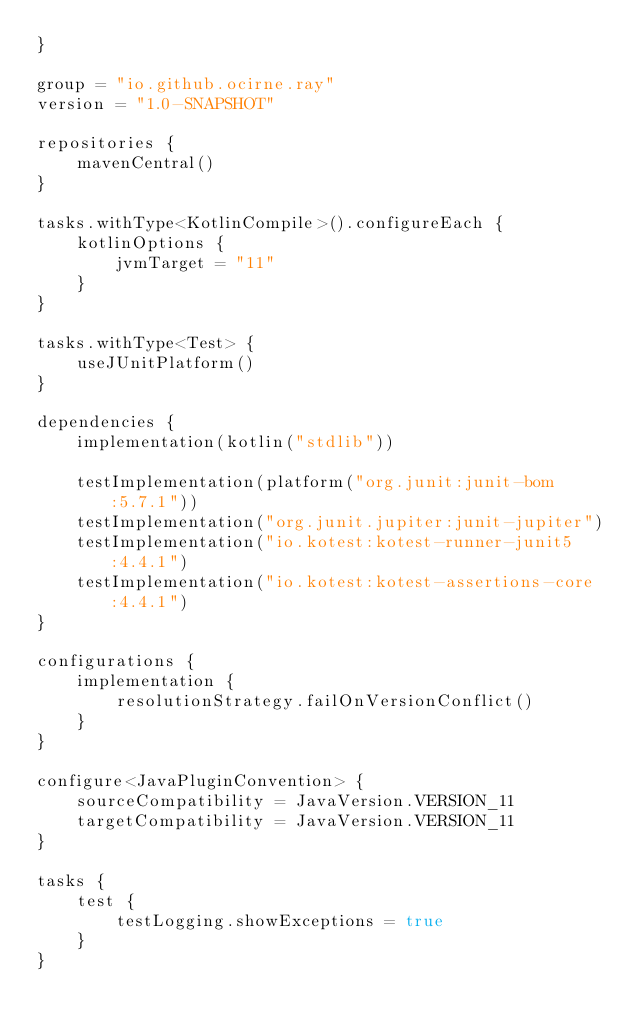Convert code to text. <code><loc_0><loc_0><loc_500><loc_500><_Kotlin_>}

group = "io.github.ocirne.ray"
version = "1.0-SNAPSHOT"

repositories {
    mavenCentral()
}

tasks.withType<KotlinCompile>().configureEach {
    kotlinOptions {
        jvmTarget = "11"
    }
}

tasks.withType<Test> {
    useJUnitPlatform()
}

dependencies {
    implementation(kotlin("stdlib"))

    testImplementation(platform("org.junit:junit-bom:5.7.1"))
    testImplementation("org.junit.jupiter:junit-jupiter")
    testImplementation("io.kotest:kotest-runner-junit5:4.4.1")
    testImplementation("io.kotest:kotest-assertions-core:4.4.1")
}

configurations {
    implementation {
        resolutionStrategy.failOnVersionConflict()
    }
}

configure<JavaPluginConvention> {
    sourceCompatibility = JavaVersion.VERSION_11
    targetCompatibility = JavaVersion.VERSION_11
}

tasks {
    test {
        testLogging.showExceptions = true
    }
}</code> 